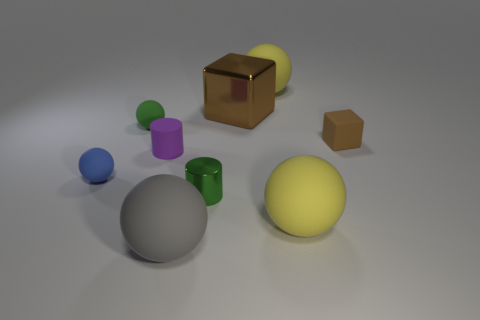Subtract all large yellow spheres. How many spheres are left? 3 Subtract all balls. How many objects are left? 4 Subtract all green balls. How many balls are left? 4 Add 1 balls. How many objects exist? 10 Subtract 1 cylinders. How many cylinders are left? 1 Subtract all red spheres. How many red cubes are left? 0 Subtract all large matte balls. Subtract all big rubber balls. How many objects are left? 3 Add 1 gray matte things. How many gray matte things are left? 2 Add 4 gray objects. How many gray objects exist? 5 Subtract 0 brown spheres. How many objects are left? 9 